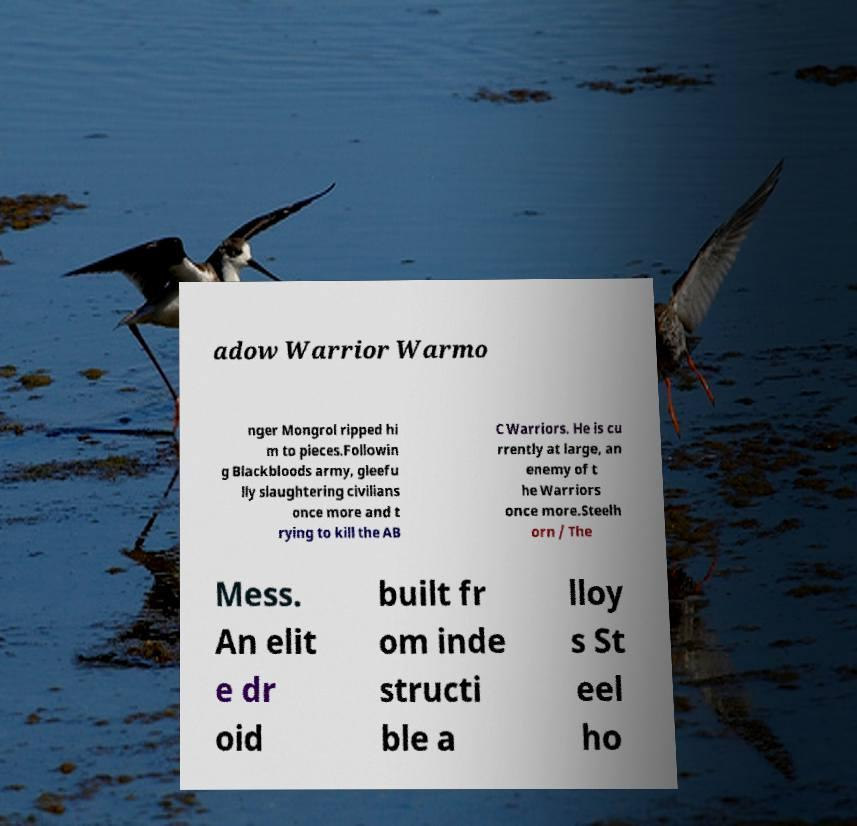There's text embedded in this image that I need extracted. Can you transcribe it verbatim? adow Warrior Warmo nger Mongrol ripped hi m to pieces.Followin g Blackbloods army, gleefu lly slaughtering civilians once more and t rying to kill the AB C Warriors. He is cu rrently at large, an enemy of t he Warriors once more.Steelh orn / The Mess. An elit e dr oid built fr om inde structi ble a lloy s St eel ho 